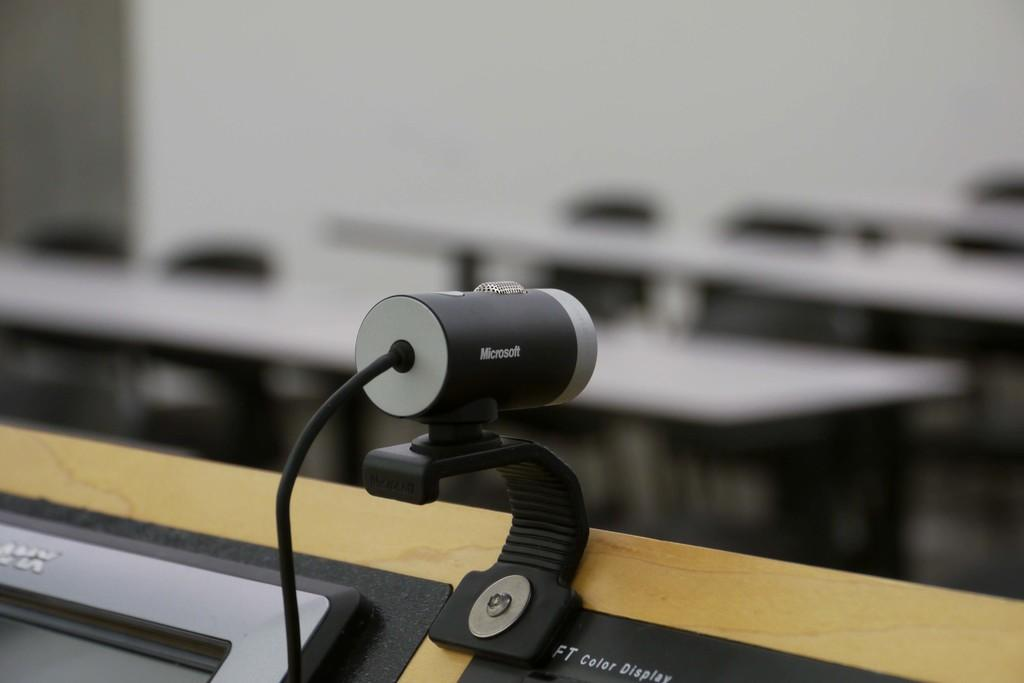What is the main object in the image? There is a gadget in the image. What type of furniture can be seen in the image? There are tables in the image. Can you describe the background of the image? The background of the image is blurry. What type of flower is growing on the gadget in the image? There is no flower present on the gadget in the image. 